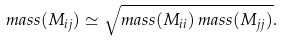Convert formula to latex. <formula><loc_0><loc_0><loc_500><loc_500>m a s s ( M _ { i j } ) \simeq \sqrt { m a s s ( M _ { i i } ) \, m a s s ( M _ { j j } ) } .</formula> 